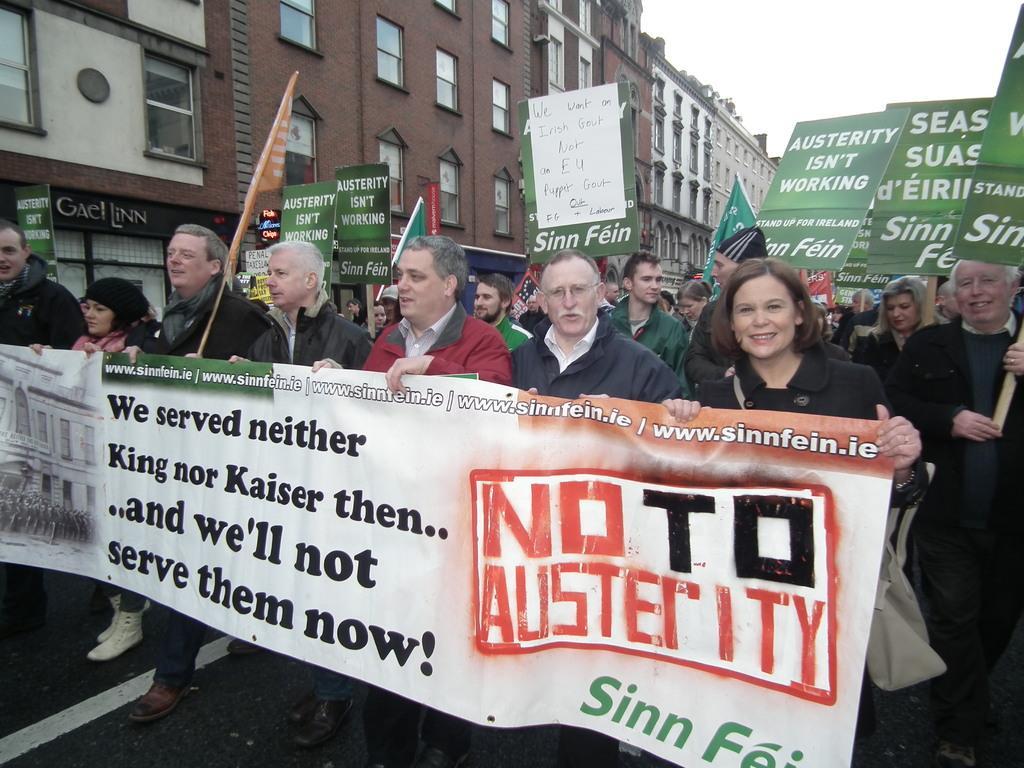Could you give a brief overview of what you see in this image? There are people holding a flex and posters in the foreground area of the image, it seems like stalls, buildings and the sky in the background. 